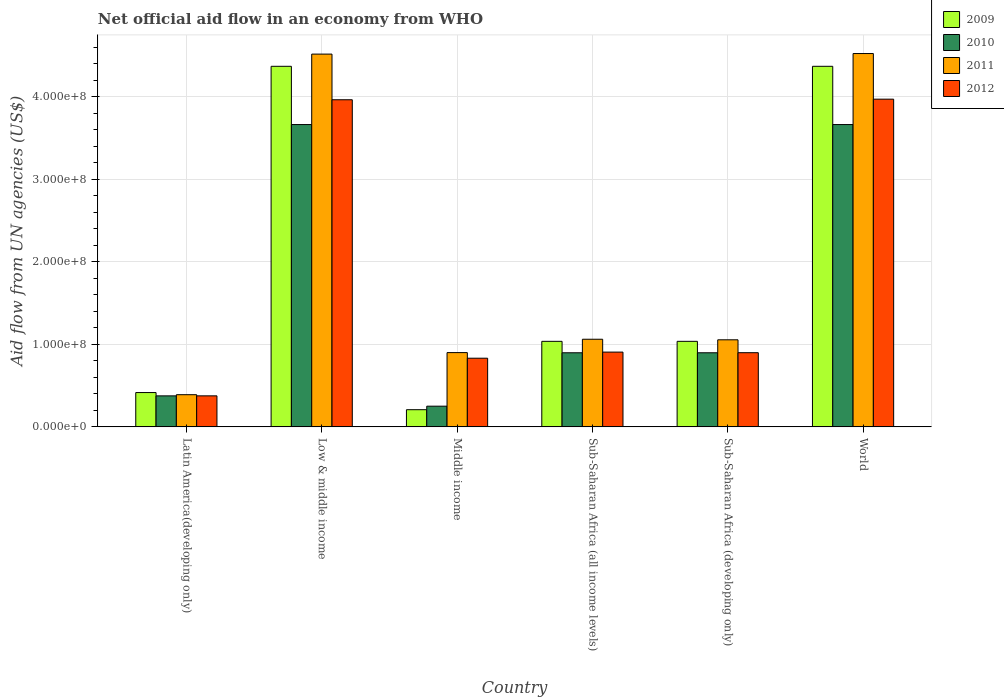How many different coloured bars are there?
Provide a short and direct response. 4. Are the number of bars per tick equal to the number of legend labels?
Provide a succinct answer. Yes. How many bars are there on the 3rd tick from the left?
Offer a terse response. 4. What is the label of the 5th group of bars from the left?
Make the answer very short. Sub-Saharan Africa (developing only). In how many cases, is the number of bars for a given country not equal to the number of legend labels?
Your answer should be compact. 0. What is the net official aid flow in 2012 in Middle income?
Ensure brevity in your answer.  8.32e+07. Across all countries, what is the maximum net official aid flow in 2011?
Ensure brevity in your answer.  4.52e+08. Across all countries, what is the minimum net official aid flow in 2012?
Give a very brief answer. 3.76e+07. In which country was the net official aid flow in 2012 minimum?
Provide a succinct answer. Latin America(developing only). What is the total net official aid flow in 2012 in the graph?
Make the answer very short. 1.09e+09. What is the difference between the net official aid flow in 2012 in Low & middle income and that in Sub-Saharan Africa (developing only)?
Keep it short and to the point. 3.06e+08. What is the difference between the net official aid flow in 2011 in World and the net official aid flow in 2009 in Middle income?
Keep it short and to the point. 4.31e+08. What is the average net official aid flow in 2009 per country?
Offer a very short reply. 1.91e+08. What is the difference between the net official aid flow of/in 2009 and net official aid flow of/in 2012 in World?
Your answer should be compact. 3.98e+07. What is the ratio of the net official aid flow in 2012 in Low & middle income to that in Sub-Saharan Africa (developing only)?
Keep it short and to the point. 4.41. Is the net official aid flow in 2010 in Low & middle income less than that in Sub-Saharan Africa (all income levels)?
Ensure brevity in your answer.  No. What is the difference between the highest and the second highest net official aid flow in 2010?
Your answer should be very brief. 2.76e+08. What is the difference between the highest and the lowest net official aid flow in 2009?
Offer a terse response. 4.16e+08. In how many countries, is the net official aid flow in 2012 greater than the average net official aid flow in 2012 taken over all countries?
Your response must be concise. 2. Is it the case that in every country, the sum of the net official aid flow in 2009 and net official aid flow in 2010 is greater than the sum of net official aid flow in 2011 and net official aid flow in 2012?
Make the answer very short. No. What does the 3rd bar from the left in World represents?
Offer a very short reply. 2011. How many countries are there in the graph?
Provide a succinct answer. 6. What is the difference between two consecutive major ticks on the Y-axis?
Offer a terse response. 1.00e+08. Does the graph contain any zero values?
Your response must be concise. No. How are the legend labels stacked?
Offer a terse response. Vertical. What is the title of the graph?
Offer a very short reply. Net official aid flow in an economy from WHO. What is the label or title of the X-axis?
Provide a succinct answer. Country. What is the label or title of the Y-axis?
Make the answer very short. Aid flow from UN agencies (US$). What is the Aid flow from UN agencies (US$) in 2009 in Latin America(developing only)?
Ensure brevity in your answer.  4.16e+07. What is the Aid flow from UN agencies (US$) of 2010 in Latin America(developing only)?
Your answer should be compact. 3.76e+07. What is the Aid flow from UN agencies (US$) in 2011 in Latin America(developing only)?
Your response must be concise. 3.90e+07. What is the Aid flow from UN agencies (US$) in 2012 in Latin America(developing only)?
Provide a succinct answer. 3.76e+07. What is the Aid flow from UN agencies (US$) of 2009 in Low & middle income?
Ensure brevity in your answer.  4.37e+08. What is the Aid flow from UN agencies (US$) of 2010 in Low & middle income?
Your response must be concise. 3.66e+08. What is the Aid flow from UN agencies (US$) in 2011 in Low & middle income?
Your answer should be compact. 4.52e+08. What is the Aid flow from UN agencies (US$) of 2012 in Low & middle income?
Your response must be concise. 3.96e+08. What is the Aid flow from UN agencies (US$) in 2009 in Middle income?
Provide a short and direct response. 2.08e+07. What is the Aid flow from UN agencies (US$) of 2010 in Middle income?
Offer a very short reply. 2.51e+07. What is the Aid flow from UN agencies (US$) in 2011 in Middle income?
Your answer should be compact. 9.00e+07. What is the Aid flow from UN agencies (US$) of 2012 in Middle income?
Provide a short and direct response. 8.32e+07. What is the Aid flow from UN agencies (US$) in 2009 in Sub-Saharan Africa (all income levels)?
Offer a very short reply. 1.04e+08. What is the Aid flow from UN agencies (US$) in 2010 in Sub-Saharan Africa (all income levels)?
Give a very brief answer. 8.98e+07. What is the Aid flow from UN agencies (US$) of 2011 in Sub-Saharan Africa (all income levels)?
Provide a succinct answer. 1.06e+08. What is the Aid flow from UN agencies (US$) of 2012 in Sub-Saharan Africa (all income levels)?
Ensure brevity in your answer.  9.06e+07. What is the Aid flow from UN agencies (US$) of 2009 in Sub-Saharan Africa (developing only)?
Give a very brief answer. 1.04e+08. What is the Aid flow from UN agencies (US$) in 2010 in Sub-Saharan Africa (developing only)?
Provide a short and direct response. 8.98e+07. What is the Aid flow from UN agencies (US$) of 2011 in Sub-Saharan Africa (developing only)?
Keep it short and to the point. 1.05e+08. What is the Aid flow from UN agencies (US$) of 2012 in Sub-Saharan Africa (developing only)?
Offer a terse response. 8.98e+07. What is the Aid flow from UN agencies (US$) in 2009 in World?
Offer a very short reply. 4.37e+08. What is the Aid flow from UN agencies (US$) in 2010 in World?
Your response must be concise. 3.66e+08. What is the Aid flow from UN agencies (US$) of 2011 in World?
Make the answer very short. 4.52e+08. What is the Aid flow from UN agencies (US$) in 2012 in World?
Make the answer very short. 3.97e+08. Across all countries, what is the maximum Aid flow from UN agencies (US$) in 2009?
Your response must be concise. 4.37e+08. Across all countries, what is the maximum Aid flow from UN agencies (US$) of 2010?
Provide a short and direct response. 3.66e+08. Across all countries, what is the maximum Aid flow from UN agencies (US$) of 2011?
Offer a terse response. 4.52e+08. Across all countries, what is the maximum Aid flow from UN agencies (US$) in 2012?
Your answer should be very brief. 3.97e+08. Across all countries, what is the minimum Aid flow from UN agencies (US$) in 2009?
Provide a short and direct response. 2.08e+07. Across all countries, what is the minimum Aid flow from UN agencies (US$) of 2010?
Your answer should be very brief. 2.51e+07. Across all countries, what is the minimum Aid flow from UN agencies (US$) in 2011?
Your answer should be compact. 3.90e+07. Across all countries, what is the minimum Aid flow from UN agencies (US$) of 2012?
Your answer should be compact. 3.76e+07. What is the total Aid flow from UN agencies (US$) in 2009 in the graph?
Offer a very short reply. 1.14e+09. What is the total Aid flow from UN agencies (US$) in 2010 in the graph?
Ensure brevity in your answer.  9.75e+08. What is the total Aid flow from UN agencies (US$) of 2011 in the graph?
Give a very brief answer. 1.24e+09. What is the total Aid flow from UN agencies (US$) of 2012 in the graph?
Your answer should be very brief. 1.09e+09. What is the difference between the Aid flow from UN agencies (US$) in 2009 in Latin America(developing only) and that in Low & middle income?
Keep it short and to the point. -3.95e+08. What is the difference between the Aid flow from UN agencies (US$) of 2010 in Latin America(developing only) and that in Low & middle income?
Provide a short and direct response. -3.29e+08. What is the difference between the Aid flow from UN agencies (US$) in 2011 in Latin America(developing only) and that in Low & middle income?
Keep it short and to the point. -4.13e+08. What is the difference between the Aid flow from UN agencies (US$) of 2012 in Latin America(developing only) and that in Low & middle income?
Your answer should be compact. -3.59e+08. What is the difference between the Aid flow from UN agencies (US$) in 2009 in Latin America(developing only) and that in Middle income?
Your response must be concise. 2.08e+07. What is the difference between the Aid flow from UN agencies (US$) of 2010 in Latin America(developing only) and that in Middle income?
Your response must be concise. 1.25e+07. What is the difference between the Aid flow from UN agencies (US$) in 2011 in Latin America(developing only) and that in Middle income?
Provide a succinct answer. -5.10e+07. What is the difference between the Aid flow from UN agencies (US$) in 2012 in Latin America(developing only) and that in Middle income?
Provide a succinct answer. -4.56e+07. What is the difference between the Aid flow from UN agencies (US$) of 2009 in Latin America(developing only) and that in Sub-Saharan Africa (all income levels)?
Your answer should be compact. -6.20e+07. What is the difference between the Aid flow from UN agencies (US$) in 2010 in Latin America(developing only) and that in Sub-Saharan Africa (all income levels)?
Provide a succinct answer. -5.22e+07. What is the difference between the Aid flow from UN agencies (US$) of 2011 in Latin America(developing only) and that in Sub-Saharan Africa (all income levels)?
Your answer should be compact. -6.72e+07. What is the difference between the Aid flow from UN agencies (US$) in 2012 in Latin America(developing only) and that in Sub-Saharan Africa (all income levels)?
Provide a succinct answer. -5.30e+07. What is the difference between the Aid flow from UN agencies (US$) of 2009 in Latin America(developing only) and that in Sub-Saharan Africa (developing only)?
Offer a terse response. -6.20e+07. What is the difference between the Aid flow from UN agencies (US$) in 2010 in Latin America(developing only) and that in Sub-Saharan Africa (developing only)?
Keep it short and to the point. -5.22e+07. What is the difference between the Aid flow from UN agencies (US$) of 2011 in Latin America(developing only) and that in Sub-Saharan Africa (developing only)?
Keep it short and to the point. -6.65e+07. What is the difference between the Aid flow from UN agencies (US$) in 2012 in Latin America(developing only) and that in Sub-Saharan Africa (developing only)?
Provide a succinct answer. -5.23e+07. What is the difference between the Aid flow from UN agencies (US$) in 2009 in Latin America(developing only) and that in World?
Offer a terse response. -3.95e+08. What is the difference between the Aid flow from UN agencies (US$) of 2010 in Latin America(developing only) and that in World?
Give a very brief answer. -3.29e+08. What is the difference between the Aid flow from UN agencies (US$) of 2011 in Latin America(developing only) and that in World?
Keep it short and to the point. -4.13e+08. What is the difference between the Aid flow from UN agencies (US$) of 2012 in Latin America(developing only) and that in World?
Give a very brief answer. -3.59e+08. What is the difference between the Aid flow from UN agencies (US$) of 2009 in Low & middle income and that in Middle income?
Ensure brevity in your answer.  4.16e+08. What is the difference between the Aid flow from UN agencies (US$) in 2010 in Low & middle income and that in Middle income?
Make the answer very short. 3.41e+08. What is the difference between the Aid flow from UN agencies (US$) of 2011 in Low & middle income and that in Middle income?
Keep it short and to the point. 3.62e+08. What is the difference between the Aid flow from UN agencies (US$) in 2012 in Low & middle income and that in Middle income?
Your answer should be compact. 3.13e+08. What is the difference between the Aid flow from UN agencies (US$) of 2009 in Low & middle income and that in Sub-Saharan Africa (all income levels)?
Make the answer very short. 3.33e+08. What is the difference between the Aid flow from UN agencies (US$) of 2010 in Low & middle income and that in Sub-Saharan Africa (all income levels)?
Provide a short and direct response. 2.76e+08. What is the difference between the Aid flow from UN agencies (US$) of 2011 in Low & middle income and that in Sub-Saharan Africa (all income levels)?
Make the answer very short. 3.45e+08. What is the difference between the Aid flow from UN agencies (US$) of 2012 in Low & middle income and that in Sub-Saharan Africa (all income levels)?
Offer a terse response. 3.06e+08. What is the difference between the Aid flow from UN agencies (US$) of 2009 in Low & middle income and that in Sub-Saharan Africa (developing only)?
Your answer should be compact. 3.33e+08. What is the difference between the Aid flow from UN agencies (US$) in 2010 in Low & middle income and that in Sub-Saharan Africa (developing only)?
Provide a short and direct response. 2.76e+08. What is the difference between the Aid flow from UN agencies (US$) in 2011 in Low & middle income and that in Sub-Saharan Africa (developing only)?
Your response must be concise. 3.46e+08. What is the difference between the Aid flow from UN agencies (US$) in 2012 in Low & middle income and that in Sub-Saharan Africa (developing only)?
Your answer should be compact. 3.06e+08. What is the difference between the Aid flow from UN agencies (US$) in 2010 in Low & middle income and that in World?
Your response must be concise. 0. What is the difference between the Aid flow from UN agencies (US$) of 2011 in Low & middle income and that in World?
Give a very brief answer. -6.70e+05. What is the difference between the Aid flow from UN agencies (US$) in 2012 in Low & middle income and that in World?
Your answer should be very brief. -7.20e+05. What is the difference between the Aid flow from UN agencies (US$) of 2009 in Middle income and that in Sub-Saharan Africa (all income levels)?
Provide a succinct answer. -8.28e+07. What is the difference between the Aid flow from UN agencies (US$) in 2010 in Middle income and that in Sub-Saharan Africa (all income levels)?
Give a very brief answer. -6.47e+07. What is the difference between the Aid flow from UN agencies (US$) in 2011 in Middle income and that in Sub-Saharan Africa (all income levels)?
Your answer should be compact. -1.62e+07. What is the difference between the Aid flow from UN agencies (US$) of 2012 in Middle income and that in Sub-Saharan Africa (all income levels)?
Provide a short and direct response. -7.39e+06. What is the difference between the Aid flow from UN agencies (US$) of 2009 in Middle income and that in Sub-Saharan Africa (developing only)?
Offer a very short reply. -8.28e+07. What is the difference between the Aid flow from UN agencies (US$) in 2010 in Middle income and that in Sub-Saharan Africa (developing only)?
Give a very brief answer. -6.47e+07. What is the difference between the Aid flow from UN agencies (US$) in 2011 in Middle income and that in Sub-Saharan Africa (developing only)?
Your answer should be very brief. -1.55e+07. What is the difference between the Aid flow from UN agencies (US$) of 2012 in Middle income and that in Sub-Saharan Africa (developing only)?
Keep it short and to the point. -6.67e+06. What is the difference between the Aid flow from UN agencies (US$) in 2009 in Middle income and that in World?
Your response must be concise. -4.16e+08. What is the difference between the Aid flow from UN agencies (US$) of 2010 in Middle income and that in World?
Offer a very short reply. -3.41e+08. What is the difference between the Aid flow from UN agencies (US$) of 2011 in Middle income and that in World?
Give a very brief answer. -3.62e+08. What is the difference between the Aid flow from UN agencies (US$) of 2012 in Middle income and that in World?
Offer a terse response. -3.14e+08. What is the difference between the Aid flow from UN agencies (US$) in 2011 in Sub-Saharan Africa (all income levels) and that in Sub-Saharan Africa (developing only)?
Ensure brevity in your answer.  6.70e+05. What is the difference between the Aid flow from UN agencies (US$) of 2012 in Sub-Saharan Africa (all income levels) and that in Sub-Saharan Africa (developing only)?
Your response must be concise. 7.20e+05. What is the difference between the Aid flow from UN agencies (US$) of 2009 in Sub-Saharan Africa (all income levels) and that in World?
Offer a terse response. -3.33e+08. What is the difference between the Aid flow from UN agencies (US$) in 2010 in Sub-Saharan Africa (all income levels) and that in World?
Ensure brevity in your answer.  -2.76e+08. What is the difference between the Aid flow from UN agencies (US$) in 2011 in Sub-Saharan Africa (all income levels) and that in World?
Offer a very short reply. -3.46e+08. What is the difference between the Aid flow from UN agencies (US$) of 2012 in Sub-Saharan Africa (all income levels) and that in World?
Your response must be concise. -3.06e+08. What is the difference between the Aid flow from UN agencies (US$) of 2009 in Sub-Saharan Africa (developing only) and that in World?
Your response must be concise. -3.33e+08. What is the difference between the Aid flow from UN agencies (US$) in 2010 in Sub-Saharan Africa (developing only) and that in World?
Ensure brevity in your answer.  -2.76e+08. What is the difference between the Aid flow from UN agencies (US$) in 2011 in Sub-Saharan Africa (developing only) and that in World?
Give a very brief answer. -3.47e+08. What is the difference between the Aid flow from UN agencies (US$) in 2012 in Sub-Saharan Africa (developing only) and that in World?
Your answer should be compact. -3.07e+08. What is the difference between the Aid flow from UN agencies (US$) of 2009 in Latin America(developing only) and the Aid flow from UN agencies (US$) of 2010 in Low & middle income?
Ensure brevity in your answer.  -3.25e+08. What is the difference between the Aid flow from UN agencies (US$) in 2009 in Latin America(developing only) and the Aid flow from UN agencies (US$) in 2011 in Low & middle income?
Make the answer very short. -4.10e+08. What is the difference between the Aid flow from UN agencies (US$) in 2009 in Latin America(developing only) and the Aid flow from UN agencies (US$) in 2012 in Low & middle income?
Your answer should be very brief. -3.55e+08. What is the difference between the Aid flow from UN agencies (US$) in 2010 in Latin America(developing only) and the Aid flow from UN agencies (US$) in 2011 in Low & middle income?
Provide a short and direct response. -4.14e+08. What is the difference between the Aid flow from UN agencies (US$) in 2010 in Latin America(developing only) and the Aid flow from UN agencies (US$) in 2012 in Low & middle income?
Keep it short and to the point. -3.59e+08. What is the difference between the Aid flow from UN agencies (US$) of 2011 in Latin America(developing only) and the Aid flow from UN agencies (US$) of 2012 in Low & middle income?
Make the answer very short. -3.57e+08. What is the difference between the Aid flow from UN agencies (US$) in 2009 in Latin America(developing only) and the Aid flow from UN agencies (US$) in 2010 in Middle income?
Provide a succinct answer. 1.65e+07. What is the difference between the Aid flow from UN agencies (US$) in 2009 in Latin America(developing only) and the Aid flow from UN agencies (US$) in 2011 in Middle income?
Provide a succinct answer. -4.84e+07. What is the difference between the Aid flow from UN agencies (US$) in 2009 in Latin America(developing only) and the Aid flow from UN agencies (US$) in 2012 in Middle income?
Ensure brevity in your answer.  -4.16e+07. What is the difference between the Aid flow from UN agencies (US$) in 2010 in Latin America(developing only) and the Aid flow from UN agencies (US$) in 2011 in Middle income?
Your answer should be very brief. -5.24e+07. What is the difference between the Aid flow from UN agencies (US$) of 2010 in Latin America(developing only) and the Aid flow from UN agencies (US$) of 2012 in Middle income?
Offer a very short reply. -4.56e+07. What is the difference between the Aid flow from UN agencies (US$) of 2011 in Latin America(developing only) and the Aid flow from UN agencies (US$) of 2012 in Middle income?
Offer a very short reply. -4.42e+07. What is the difference between the Aid flow from UN agencies (US$) of 2009 in Latin America(developing only) and the Aid flow from UN agencies (US$) of 2010 in Sub-Saharan Africa (all income levels)?
Provide a short and direct response. -4.82e+07. What is the difference between the Aid flow from UN agencies (US$) of 2009 in Latin America(developing only) and the Aid flow from UN agencies (US$) of 2011 in Sub-Saharan Africa (all income levels)?
Keep it short and to the point. -6.46e+07. What is the difference between the Aid flow from UN agencies (US$) in 2009 in Latin America(developing only) and the Aid flow from UN agencies (US$) in 2012 in Sub-Saharan Africa (all income levels)?
Offer a terse response. -4.90e+07. What is the difference between the Aid flow from UN agencies (US$) of 2010 in Latin America(developing only) and the Aid flow from UN agencies (US$) of 2011 in Sub-Saharan Africa (all income levels)?
Offer a very short reply. -6.86e+07. What is the difference between the Aid flow from UN agencies (US$) in 2010 in Latin America(developing only) and the Aid flow from UN agencies (US$) in 2012 in Sub-Saharan Africa (all income levels)?
Keep it short and to the point. -5.30e+07. What is the difference between the Aid flow from UN agencies (US$) in 2011 in Latin America(developing only) and the Aid flow from UN agencies (US$) in 2012 in Sub-Saharan Africa (all income levels)?
Offer a very short reply. -5.16e+07. What is the difference between the Aid flow from UN agencies (US$) in 2009 in Latin America(developing only) and the Aid flow from UN agencies (US$) in 2010 in Sub-Saharan Africa (developing only)?
Provide a short and direct response. -4.82e+07. What is the difference between the Aid flow from UN agencies (US$) of 2009 in Latin America(developing only) and the Aid flow from UN agencies (US$) of 2011 in Sub-Saharan Africa (developing only)?
Make the answer very short. -6.39e+07. What is the difference between the Aid flow from UN agencies (US$) in 2009 in Latin America(developing only) and the Aid flow from UN agencies (US$) in 2012 in Sub-Saharan Africa (developing only)?
Give a very brief answer. -4.83e+07. What is the difference between the Aid flow from UN agencies (US$) in 2010 in Latin America(developing only) and the Aid flow from UN agencies (US$) in 2011 in Sub-Saharan Africa (developing only)?
Your answer should be compact. -6.79e+07. What is the difference between the Aid flow from UN agencies (US$) in 2010 in Latin America(developing only) and the Aid flow from UN agencies (US$) in 2012 in Sub-Saharan Africa (developing only)?
Make the answer very short. -5.23e+07. What is the difference between the Aid flow from UN agencies (US$) of 2011 in Latin America(developing only) and the Aid flow from UN agencies (US$) of 2012 in Sub-Saharan Africa (developing only)?
Make the answer very short. -5.09e+07. What is the difference between the Aid flow from UN agencies (US$) of 2009 in Latin America(developing only) and the Aid flow from UN agencies (US$) of 2010 in World?
Your answer should be compact. -3.25e+08. What is the difference between the Aid flow from UN agencies (US$) of 2009 in Latin America(developing only) and the Aid flow from UN agencies (US$) of 2011 in World?
Provide a short and direct response. -4.11e+08. What is the difference between the Aid flow from UN agencies (US$) of 2009 in Latin America(developing only) and the Aid flow from UN agencies (US$) of 2012 in World?
Provide a succinct answer. -3.55e+08. What is the difference between the Aid flow from UN agencies (US$) of 2010 in Latin America(developing only) and the Aid flow from UN agencies (US$) of 2011 in World?
Your response must be concise. -4.15e+08. What is the difference between the Aid flow from UN agencies (US$) of 2010 in Latin America(developing only) and the Aid flow from UN agencies (US$) of 2012 in World?
Ensure brevity in your answer.  -3.59e+08. What is the difference between the Aid flow from UN agencies (US$) in 2011 in Latin America(developing only) and the Aid flow from UN agencies (US$) in 2012 in World?
Your response must be concise. -3.58e+08. What is the difference between the Aid flow from UN agencies (US$) of 2009 in Low & middle income and the Aid flow from UN agencies (US$) of 2010 in Middle income?
Your answer should be very brief. 4.12e+08. What is the difference between the Aid flow from UN agencies (US$) in 2009 in Low & middle income and the Aid flow from UN agencies (US$) in 2011 in Middle income?
Ensure brevity in your answer.  3.47e+08. What is the difference between the Aid flow from UN agencies (US$) of 2009 in Low & middle income and the Aid flow from UN agencies (US$) of 2012 in Middle income?
Ensure brevity in your answer.  3.54e+08. What is the difference between the Aid flow from UN agencies (US$) of 2010 in Low & middle income and the Aid flow from UN agencies (US$) of 2011 in Middle income?
Offer a terse response. 2.76e+08. What is the difference between the Aid flow from UN agencies (US$) in 2010 in Low & middle income and the Aid flow from UN agencies (US$) in 2012 in Middle income?
Offer a terse response. 2.83e+08. What is the difference between the Aid flow from UN agencies (US$) in 2011 in Low & middle income and the Aid flow from UN agencies (US$) in 2012 in Middle income?
Provide a short and direct response. 3.68e+08. What is the difference between the Aid flow from UN agencies (US$) of 2009 in Low & middle income and the Aid flow from UN agencies (US$) of 2010 in Sub-Saharan Africa (all income levels)?
Keep it short and to the point. 3.47e+08. What is the difference between the Aid flow from UN agencies (US$) in 2009 in Low & middle income and the Aid flow from UN agencies (US$) in 2011 in Sub-Saharan Africa (all income levels)?
Keep it short and to the point. 3.31e+08. What is the difference between the Aid flow from UN agencies (US$) in 2009 in Low & middle income and the Aid flow from UN agencies (US$) in 2012 in Sub-Saharan Africa (all income levels)?
Offer a terse response. 3.46e+08. What is the difference between the Aid flow from UN agencies (US$) in 2010 in Low & middle income and the Aid flow from UN agencies (US$) in 2011 in Sub-Saharan Africa (all income levels)?
Your answer should be very brief. 2.60e+08. What is the difference between the Aid flow from UN agencies (US$) in 2010 in Low & middle income and the Aid flow from UN agencies (US$) in 2012 in Sub-Saharan Africa (all income levels)?
Give a very brief answer. 2.76e+08. What is the difference between the Aid flow from UN agencies (US$) of 2011 in Low & middle income and the Aid flow from UN agencies (US$) of 2012 in Sub-Saharan Africa (all income levels)?
Your answer should be compact. 3.61e+08. What is the difference between the Aid flow from UN agencies (US$) of 2009 in Low & middle income and the Aid flow from UN agencies (US$) of 2010 in Sub-Saharan Africa (developing only)?
Make the answer very short. 3.47e+08. What is the difference between the Aid flow from UN agencies (US$) of 2009 in Low & middle income and the Aid flow from UN agencies (US$) of 2011 in Sub-Saharan Africa (developing only)?
Keep it short and to the point. 3.31e+08. What is the difference between the Aid flow from UN agencies (US$) in 2009 in Low & middle income and the Aid flow from UN agencies (US$) in 2012 in Sub-Saharan Africa (developing only)?
Give a very brief answer. 3.47e+08. What is the difference between the Aid flow from UN agencies (US$) in 2010 in Low & middle income and the Aid flow from UN agencies (US$) in 2011 in Sub-Saharan Africa (developing only)?
Give a very brief answer. 2.61e+08. What is the difference between the Aid flow from UN agencies (US$) of 2010 in Low & middle income and the Aid flow from UN agencies (US$) of 2012 in Sub-Saharan Africa (developing only)?
Provide a short and direct response. 2.76e+08. What is the difference between the Aid flow from UN agencies (US$) of 2011 in Low & middle income and the Aid flow from UN agencies (US$) of 2012 in Sub-Saharan Africa (developing only)?
Ensure brevity in your answer.  3.62e+08. What is the difference between the Aid flow from UN agencies (US$) of 2009 in Low & middle income and the Aid flow from UN agencies (US$) of 2010 in World?
Make the answer very short. 7.06e+07. What is the difference between the Aid flow from UN agencies (US$) of 2009 in Low & middle income and the Aid flow from UN agencies (US$) of 2011 in World?
Offer a terse response. -1.55e+07. What is the difference between the Aid flow from UN agencies (US$) in 2009 in Low & middle income and the Aid flow from UN agencies (US$) in 2012 in World?
Offer a very short reply. 3.98e+07. What is the difference between the Aid flow from UN agencies (US$) in 2010 in Low & middle income and the Aid flow from UN agencies (US$) in 2011 in World?
Give a very brief answer. -8.60e+07. What is the difference between the Aid flow from UN agencies (US$) in 2010 in Low & middle income and the Aid flow from UN agencies (US$) in 2012 in World?
Your answer should be compact. -3.08e+07. What is the difference between the Aid flow from UN agencies (US$) in 2011 in Low & middle income and the Aid flow from UN agencies (US$) in 2012 in World?
Ensure brevity in your answer.  5.46e+07. What is the difference between the Aid flow from UN agencies (US$) of 2009 in Middle income and the Aid flow from UN agencies (US$) of 2010 in Sub-Saharan Africa (all income levels)?
Make the answer very short. -6.90e+07. What is the difference between the Aid flow from UN agencies (US$) in 2009 in Middle income and the Aid flow from UN agencies (US$) in 2011 in Sub-Saharan Africa (all income levels)?
Make the answer very short. -8.54e+07. What is the difference between the Aid flow from UN agencies (US$) of 2009 in Middle income and the Aid flow from UN agencies (US$) of 2012 in Sub-Saharan Africa (all income levels)?
Your answer should be compact. -6.98e+07. What is the difference between the Aid flow from UN agencies (US$) in 2010 in Middle income and the Aid flow from UN agencies (US$) in 2011 in Sub-Saharan Africa (all income levels)?
Keep it short and to the point. -8.11e+07. What is the difference between the Aid flow from UN agencies (US$) of 2010 in Middle income and the Aid flow from UN agencies (US$) of 2012 in Sub-Saharan Africa (all income levels)?
Offer a very short reply. -6.55e+07. What is the difference between the Aid flow from UN agencies (US$) in 2011 in Middle income and the Aid flow from UN agencies (US$) in 2012 in Sub-Saharan Africa (all income levels)?
Your response must be concise. -5.90e+05. What is the difference between the Aid flow from UN agencies (US$) of 2009 in Middle income and the Aid flow from UN agencies (US$) of 2010 in Sub-Saharan Africa (developing only)?
Your answer should be compact. -6.90e+07. What is the difference between the Aid flow from UN agencies (US$) in 2009 in Middle income and the Aid flow from UN agencies (US$) in 2011 in Sub-Saharan Africa (developing only)?
Your answer should be compact. -8.47e+07. What is the difference between the Aid flow from UN agencies (US$) of 2009 in Middle income and the Aid flow from UN agencies (US$) of 2012 in Sub-Saharan Africa (developing only)?
Offer a terse response. -6.90e+07. What is the difference between the Aid flow from UN agencies (US$) of 2010 in Middle income and the Aid flow from UN agencies (US$) of 2011 in Sub-Saharan Africa (developing only)?
Your response must be concise. -8.04e+07. What is the difference between the Aid flow from UN agencies (US$) in 2010 in Middle income and the Aid flow from UN agencies (US$) in 2012 in Sub-Saharan Africa (developing only)?
Provide a short and direct response. -6.48e+07. What is the difference between the Aid flow from UN agencies (US$) of 2009 in Middle income and the Aid flow from UN agencies (US$) of 2010 in World?
Ensure brevity in your answer.  -3.45e+08. What is the difference between the Aid flow from UN agencies (US$) of 2009 in Middle income and the Aid flow from UN agencies (US$) of 2011 in World?
Your answer should be very brief. -4.31e+08. What is the difference between the Aid flow from UN agencies (US$) of 2009 in Middle income and the Aid flow from UN agencies (US$) of 2012 in World?
Offer a very short reply. -3.76e+08. What is the difference between the Aid flow from UN agencies (US$) of 2010 in Middle income and the Aid flow from UN agencies (US$) of 2011 in World?
Your answer should be very brief. -4.27e+08. What is the difference between the Aid flow from UN agencies (US$) in 2010 in Middle income and the Aid flow from UN agencies (US$) in 2012 in World?
Ensure brevity in your answer.  -3.72e+08. What is the difference between the Aid flow from UN agencies (US$) in 2011 in Middle income and the Aid flow from UN agencies (US$) in 2012 in World?
Your answer should be very brief. -3.07e+08. What is the difference between the Aid flow from UN agencies (US$) of 2009 in Sub-Saharan Africa (all income levels) and the Aid flow from UN agencies (US$) of 2010 in Sub-Saharan Africa (developing only)?
Provide a short and direct response. 1.39e+07. What is the difference between the Aid flow from UN agencies (US$) of 2009 in Sub-Saharan Africa (all income levels) and the Aid flow from UN agencies (US$) of 2011 in Sub-Saharan Africa (developing only)?
Keep it short and to the point. -1.86e+06. What is the difference between the Aid flow from UN agencies (US$) in 2009 in Sub-Saharan Africa (all income levels) and the Aid flow from UN agencies (US$) in 2012 in Sub-Saharan Africa (developing only)?
Make the answer very short. 1.38e+07. What is the difference between the Aid flow from UN agencies (US$) in 2010 in Sub-Saharan Africa (all income levels) and the Aid flow from UN agencies (US$) in 2011 in Sub-Saharan Africa (developing only)?
Make the answer very short. -1.57e+07. What is the difference between the Aid flow from UN agencies (US$) in 2011 in Sub-Saharan Africa (all income levels) and the Aid flow from UN agencies (US$) in 2012 in Sub-Saharan Africa (developing only)?
Make the answer very short. 1.63e+07. What is the difference between the Aid flow from UN agencies (US$) in 2009 in Sub-Saharan Africa (all income levels) and the Aid flow from UN agencies (US$) in 2010 in World?
Make the answer very short. -2.63e+08. What is the difference between the Aid flow from UN agencies (US$) of 2009 in Sub-Saharan Africa (all income levels) and the Aid flow from UN agencies (US$) of 2011 in World?
Keep it short and to the point. -3.49e+08. What is the difference between the Aid flow from UN agencies (US$) in 2009 in Sub-Saharan Africa (all income levels) and the Aid flow from UN agencies (US$) in 2012 in World?
Offer a terse response. -2.93e+08. What is the difference between the Aid flow from UN agencies (US$) of 2010 in Sub-Saharan Africa (all income levels) and the Aid flow from UN agencies (US$) of 2011 in World?
Ensure brevity in your answer.  -3.62e+08. What is the difference between the Aid flow from UN agencies (US$) of 2010 in Sub-Saharan Africa (all income levels) and the Aid flow from UN agencies (US$) of 2012 in World?
Make the answer very short. -3.07e+08. What is the difference between the Aid flow from UN agencies (US$) in 2011 in Sub-Saharan Africa (all income levels) and the Aid flow from UN agencies (US$) in 2012 in World?
Make the answer very short. -2.91e+08. What is the difference between the Aid flow from UN agencies (US$) of 2009 in Sub-Saharan Africa (developing only) and the Aid flow from UN agencies (US$) of 2010 in World?
Give a very brief answer. -2.63e+08. What is the difference between the Aid flow from UN agencies (US$) of 2009 in Sub-Saharan Africa (developing only) and the Aid flow from UN agencies (US$) of 2011 in World?
Give a very brief answer. -3.49e+08. What is the difference between the Aid flow from UN agencies (US$) in 2009 in Sub-Saharan Africa (developing only) and the Aid flow from UN agencies (US$) in 2012 in World?
Provide a succinct answer. -2.93e+08. What is the difference between the Aid flow from UN agencies (US$) of 2010 in Sub-Saharan Africa (developing only) and the Aid flow from UN agencies (US$) of 2011 in World?
Your response must be concise. -3.62e+08. What is the difference between the Aid flow from UN agencies (US$) in 2010 in Sub-Saharan Africa (developing only) and the Aid flow from UN agencies (US$) in 2012 in World?
Give a very brief answer. -3.07e+08. What is the difference between the Aid flow from UN agencies (US$) in 2011 in Sub-Saharan Africa (developing only) and the Aid flow from UN agencies (US$) in 2012 in World?
Offer a very short reply. -2.92e+08. What is the average Aid flow from UN agencies (US$) of 2009 per country?
Your answer should be very brief. 1.91e+08. What is the average Aid flow from UN agencies (US$) of 2010 per country?
Provide a succinct answer. 1.62e+08. What is the average Aid flow from UN agencies (US$) of 2011 per country?
Provide a succinct answer. 2.07e+08. What is the average Aid flow from UN agencies (US$) in 2012 per country?
Your response must be concise. 1.82e+08. What is the difference between the Aid flow from UN agencies (US$) of 2009 and Aid flow from UN agencies (US$) of 2010 in Latin America(developing only)?
Provide a succinct answer. 4.01e+06. What is the difference between the Aid flow from UN agencies (US$) of 2009 and Aid flow from UN agencies (US$) of 2011 in Latin America(developing only)?
Provide a short and direct response. 2.59e+06. What is the difference between the Aid flow from UN agencies (US$) of 2009 and Aid flow from UN agencies (US$) of 2012 in Latin America(developing only)?
Give a very brief answer. 3.99e+06. What is the difference between the Aid flow from UN agencies (US$) in 2010 and Aid flow from UN agencies (US$) in 2011 in Latin America(developing only)?
Ensure brevity in your answer.  -1.42e+06. What is the difference between the Aid flow from UN agencies (US$) of 2010 and Aid flow from UN agencies (US$) of 2012 in Latin America(developing only)?
Keep it short and to the point. -2.00e+04. What is the difference between the Aid flow from UN agencies (US$) of 2011 and Aid flow from UN agencies (US$) of 2012 in Latin America(developing only)?
Your answer should be compact. 1.40e+06. What is the difference between the Aid flow from UN agencies (US$) in 2009 and Aid flow from UN agencies (US$) in 2010 in Low & middle income?
Offer a terse response. 7.06e+07. What is the difference between the Aid flow from UN agencies (US$) in 2009 and Aid flow from UN agencies (US$) in 2011 in Low & middle income?
Provide a succinct answer. -1.48e+07. What is the difference between the Aid flow from UN agencies (US$) in 2009 and Aid flow from UN agencies (US$) in 2012 in Low & middle income?
Make the answer very short. 4.05e+07. What is the difference between the Aid flow from UN agencies (US$) of 2010 and Aid flow from UN agencies (US$) of 2011 in Low & middle income?
Offer a very short reply. -8.54e+07. What is the difference between the Aid flow from UN agencies (US$) in 2010 and Aid flow from UN agencies (US$) in 2012 in Low & middle income?
Make the answer very short. -3.00e+07. What is the difference between the Aid flow from UN agencies (US$) of 2011 and Aid flow from UN agencies (US$) of 2012 in Low & middle income?
Provide a short and direct response. 5.53e+07. What is the difference between the Aid flow from UN agencies (US$) in 2009 and Aid flow from UN agencies (US$) in 2010 in Middle income?
Your answer should be very brief. -4.27e+06. What is the difference between the Aid flow from UN agencies (US$) of 2009 and Aid flow from UN agencies (US$) of 2011 in Middle income?
Make the answer very short. -6.92e+07. What is the difference between the Aid flow from UN agencies (US$) of 2009 and Aid flow from UN agencies (US$) of 2012 in Middle income?
Provide a short and direct response. -6.24e+07. What is the difference between the Aid flow from UN agencies (US$) in 2010 and Aid flow from UN agencies (US$) in 2011 in Middle income?
Keep it short and to the point. -6.49e+07. What is the difference between the Aid flow from UN agencies (US$) in 2010 and Aid flow from UN agencies (US$) in 2012 in Middle income?
Your answer should be compact. -5.81e+07. What is the difference between the Aid flow from UN agencies (US$) in 2011 and Aid flow from UN agencies (US$) in 2012 in Middle income?
Ensure brevity in your answer.  6.80e+06. What is the difference between the Aid flow from UN agencies (US$) of 2009 and Aid flow from UN agencies (US$) of 2010 in Sub-Saharan Africa (all income levels)?
Make the answer very short. 1.39e+07. What is the difference between the Aid flow from UN agencies (US$) in 2009 and Aid flow from UN agencies (US$) in 2011 in Sub-Saharan Africa (all income levels)?
Provide a succinct answer. -2.53e+06. What is the difference between the Aid flow from UN agencies (US$) in 2009 and Aid flow from UN agencies (US$) in 2012 in Sub-Saharan Africa (all income levels)?
Ensure brevity in your answer.  1.30e+07. What is the difference between the Aid flow from UN agencies (US$) of 2010 and Aid flow from UN agencies (US$) of 2011 in Sub-Saharan Africa (all income levels)?
Offer a terse response. -1.64e+07. What is the difference between the Aid flow from UN agencies (US$) of 2010 and Aid flow from UN agencies (US$) of 2012 in Sub-Saharan Africa (all income levels)?
Ensure brevity in your answer.  -8.10e+05. What is the difference between the Aid flow from UN agencies (US$) of 2011 and Aid flow from UN agencies (US$) of 2012 in Sub-Saharan Africa (all income levels)?
Make the answer very short. 1.56e+07. What is the difference between the Aid flow from UN agencies (US$) of 2009 and Aid flow from UN agencies (US$) of 2010 in Sub-Saharan Africa (developing only)?
Provide a short and direct response. 1.39e+07. What is the difference between the Aid flow from UN agencies (US$) in 2009 and Aid flow from UN agencies (US$) in 2011 in Sub-Saharan Africa (developing only)?
Provide a succinct answer. -1.86e+06. What is the difference between the Aid flow from UN agencies (US$) of 2009 and Aid flow from UN agencies (US$) of 2012 in Sub-Saharan Africa (developing only)?
Keep it short and to the point. 1.38e+07. What is the difference between the Aid flow from UN agencies (US$) in 2010 and Aid flow from UN agencies (US$) in 2011 in Sub-Saharan Africa (developing only)?
Make the answer very short. -1.57e+07. What is the difference between the Aid flow from UN agencies (US$) in 2011 and Aid flow from UN agencies (US$) in 2012 in Sub-Saharan Africa (developing only)?
Your answer should be compact. 1.56e+07. What is the difference between the Aid flow from UN agencies (US$) of 2009 and Aid flow from UN agencies (US$) of 2010 in World?
Make the answer very short. 7.06e+07. What is the difference between the Aid flow from UN agencies (US$) of 2009 and Aid flow from UN agencies (US$) of 2011 in World?
Offer a terse response. -1.55e+07. What is the difference between the Aid flow from UN agencies (US$) in 2009 and Aid flow from UN agencies (US$) in 2012 in World?
Keep it short and to the point. 3.98e+07. What is the difference between the Aid flow from UN agencies (US$) of 2010 and Aid flow from UN agencies (US$) of 2011 in World?
Your response must be concise. -8.60e+07. What is the difference between the Aid flow from UN agencies (US$) in 2010 and Aid flow from UN agencies (US$) in 2012 in World?
Ensure brevity in your answer.  -3.08e+07. What is the difference between the Aid flow from UN agencies (US$) of 2011 and Aid flow from UN agencies (US$) of 2012 in World?
Provide a succinct answer. 5.53e+07. What is the ratio of the Aid flow from UN agencies (US$) of 2009 in Latin America(developing only) to that in Low & middle income?
Offer a very short reply. 0.1. What is the ratio of the Aid flow from UN agencies (US$) of 2010 in Latin America(developing only) to that in Low & middle income?
Keep it short and to the point. 0.1. What is the ratio of the Aid flow from UN agencies (US$) of 2011 in Latin America(developing only) to that in Low & middle income?
Your response must be concise. 0.09. What is the ratio of the Aid flow from UN agencies (US$) of 2012 in Latin America(developing only) to that in Low & middle income?
Give a very brief answer. 0.09. What is the ratio of the Aid flow from UN agencies (US$) of 2009 in Latin America(developing only) to that in Middle income?
Your answer should be very brief. 2. What is the ratio of the Aid flow from UN agencies (US$) of 2010 in Latin America(developing only) to that in Middle income?
Ensure brevity in your answer.  1.5. What is the ratio of the Aid flow from UN agencies (US$) in 2011 in Latin America(developing only) to that in Middle income?
Give a very brief answer. 0.43. What is the ratio of the Aid flow from UN agencies (US$) of 2012 in Latin America(developing only) to that in Middle income?
Keep it short and to the point. 0.45. What is the ratio of the Aid flow from UN agencies (US$) in 2009 in Latin America(developing only) to that in Sub-Saharan Africa (all income levels)?
Your response must be concise. 0.4. What is the ratio of the Aid flow from UN agencies (US$) in 2010 in Latin America(developing only) to that in Sub-Saharan Africa (all income levels)?
Your response must be concise. 0.42. What is the ratio of the Aid flow from UN agencies (US$) of 2011 in Latin America(developing only) to that in Sub-Saharan Africa (all income levels)?
Provide a short and direct response. 0.37. What is the ratio of the Aid flow from UN agencies (US$) of 2012 in Latin America(developing only) to that in Sub-Saharan Africa (all income levels)?
Provide a short and direct response. 0.41. What is the ratio of the Aid flow from UN agencies (US$) in 2009 in Latin America(developing only) to that in Sub-Saharan Africa (developing only)?
Your response must be concise. 0.4. What is the ratio of the Aid flow from UN agencies (US$) in 2010 in Latin America(developing only) to that in Sub-Saharan Africa (developing only)?
Ensure brevity in your answer.  0.42. What is the ratio of the Aid flow from UN agencies (US$) in 2011 in Latin America(developing only) to that in Sub-Saharan Africa (developing only)?
Give a very brief answer. 0.37. What is the ratio of the Aid flow from UN agencies (US$) in 2012 in Latin America(developing only) to that in Sub-Saharan Africa (developing only)?
Provide a succinct answer. 0.42. What is the ratio of the Aid flow from UN agencies (US$) in 2009 in Latin America(developing only) to that in World?
Make the answer very short. 0.1. What is the ratio of the Aid flow from UN agencies (US$) in 2010 in Latin America(developing only) to that in World?
Your response must be concise. 0.1. What is the ratio of the Aid flow from UN agencies (US$) in 2011 in Latin America(developing only) to that in World?
Provide a short and direct response. 0.09. What is the ratio of the Aid flow from UN agencies (US$) of 2012 in Latin America(developing only) to that in World?
Your response must be concise. 0.09. What is the ratio of the Aid flow from UN agencies (US$) of 2009 in Low & middle income to that in Middle income?
Your answer should be compact. 21. What is the ratio of the Aid flow from UN agencies (US$) in 2010 in Low & middle income to that in Middle income?
Keep it short and to the point. 14.61. What is the ratio of the Aid flow from UN agencies (US$) of 2011 in Low & middle income to that in Middle income?
Ensure brevity in your answer.  5.02. What is the ratio of the Aid flow from UN agencies (US$) in 2012 in Low & middle income to that in Middle income?
Provide a succinct answer. 4.76. What is the ratio of the Aid flow from UN agencies (US$) in 2009 in Low & middle income to that in Sub-Saharan Africa (all income levels)?
Ensure brevity in your answer.  4.22. What is the ratio of the Aid flow from UN agencies (US$) of 2010 in Low & middle income to that in Sub-Saharan Africa (all income levels)?
Offer a terse response. 4.08. What is the ratio of the Aid flow from UN agencies (US$) in 2011 in Low & middle income to that in Sub-Saharan Africa (all income levels)?
Your answer should be very brief. 4.25. What is the ratio of the Aid flow from UN agencies (US$) of 2012 in Low & middle income to that in Sub-Saharan Africa (all income levels)?
Provide a succinct answer. 4.38. What is the ratio of the Aid flow from UN agencies (US$) in 2009 in Low & middle income to that in Sub-Saharan Africa (developing only)?
Provide a short and direct response. 4.22. What is the ratio of the Aid flow from UN agencies (US$) in 2010 in Low & middle income to that in Sub-Saharan Africa (developing only)?
Offer a very short reply. 4.08. What is the ratio of the Aid flow from UN agencies (US$) in 2011 in Low & middle income to that in Sub-Saharan Africa (developing only)?
Offer a very short reply. 4.28. What is the ratio of the Aid flow from UN agencies (US$) in 2012 in Low & middle income to that in Sub-Saharan Africa (developing only)?
Keep it short and to the point. 4.41. What is the ratio of the Aid flow from UN agencies (US$) in 2009 in Low & middle income to that in World?
Ensure brevity in your answer.  1. What is the ratio of the Aid flow from UN agencies (US$) in 2010 in Low & middle income to that in World?
Your answer should be compact. 1. What is the ratio of the Aid flow from UN agencies (US$) of 2011 in Low & middle income to that in World?
Offer a very short reply. 1. What is the ratio of the Aid flow from UN agencies (US$) of 2012 in Low & middle income to that in World?
Your answer should be very brief. 1. What is the ratio of the Aid flow from UN agencies (US$) of 2009 in Middle income to that in Sub-Saharan Africa (all income levels)?
Offer a very short reply. 0.2. What is the ratio of the Aid flow from UN agencies (US$) in 2010 in Middle income to that in Sub-Saharan Africa (all income levels)?
Keep it short and to the point. 0.28. What is the ratio of the Aid flow from UN agencies (US$) in 2011 in Middle income to that in Sub-Saharan Africa (all income levels)?
Your answer should be very brief. 0.85. What is the ratio of the Aid flow from UN agencies (US$) in 2012 in Middle income to that in Sub-Saharan Africa (all income levels)?
Make the answer very short. 0.92. What is the ratio of the Aid flow from UN agencies (US$) of 2009 in Middle income to that in Sub-Saharan Africa (developing only)?
Offer a terse response. 0.2. What is the ratio of the Aid flow from UN agencies (US$) of 2010 in Middle income to that in Sub-Saharan Africa (developing only)?
Your answer should be very brief. 0.28. What is the ratio of the Aid flow from UN agencies (US$) of 2011 in Middle income to that in Sub-Saharan Africa (developing only)?
Provide a succinct answer. 0.85. What is the ratio of the Aid flow from UN agencies (US$) in 2012 in Middle income to that in Sub-Saharan Africa (developing only)?
Offer a terse response. 0.93. What is the ratio of the Aid flow from UN agencies (US$) of 2009 in Middle income to that in World?
Your answer should be compact. 0.05. What is the ratio of the Aid flow from UN agencies (US$) of 2010 in Middle income to that in World?
Provide a succinct answer. 0.07. What is the ratio of the Aid flow from UN agencies (US$) in 2011 in Middle income to that in World?
Provide a short and direct response. 0.2. What is the ratio of the Aid flow from UN agencies (US$) of 2012 in Middle income to that in World?
Keep it short and to the point. 0.21. What is the ratio of the Aid flow from UN agencies (US$) of 2011 in Sub-Saharan Africa (all income levels) to that in Sub-Saharan Africa (developing only)?
Make the answer very short. 1.01. What is the ratio of the Aid flow from UN agencies (US$) of 2009 in Sub-Saharan Africa (all income levels) to that in World?
Your response must be concise. 0.24. What is the ratio of the Aid flow from UN agencies (US$) of 2010 in Sub-Saharan Africa (all income levels) to that in World?
Offer a very short reply. 0.25. What is the ratio of the Aid flow from UN agencies (US$) in 2011 in Sub-Saharan Africa (all income levels) to that in World?
Provide a succinct answer. 0.23. What is the ratio of the Aid flow from UN agencies (US$) in 2012 in Sub-Saharan Africa (all income levels) to that in World?
Provide a short and direct response. 0.23. What is the ratio of the Aid flow from UN agencies (US$) of 2009 in Sub-Saharan Africa (developing only) to that in World?
Your response must be concise. 0.24. What is the ratio of the Aid flow from UN agencies (US$) of 2010 in Sub-Saharan Africa (developing only) to that in World?
Ensure brevity in your answer.  0.25. What is the ratio of the Aid flow from UN agencies (US$) in 2011 in Sub-Saharan Africa (developing only) to that in World?
Provide a short and direct response. 0.23. What is the ratio of the Aid flow from UN agencies (US$) in 2012 in Sub-Saharan Africa (developing only) to that in World?
Your answer should be compact. 0.23. What is the difference between the highest and the second highest Aid flow from UN agencies (US$) of 2011?
Offer a very short reply. 6.70e+05. What is the difference between the highest and the second highest Aid flow from UN agencies (US$) of 2012?
Ensure brevity in your answer.  7.20e+05. What is the difference between the highest and the lowest Aid flow from UN agencies (US$) in 2009?
Your answer should be very brief. 4.16e+08. What is the difference between the highest and the lowest Aid flow from UN agencies (US$) in 2010?
Make the answer very short. 3.41e+08. What is the difference between the highest and the lowest Aid flow from UN agencies (US$) of 2011?
Offer a terse response. 4.13e+08. What is the difference between the highest and the lowest Aid flow from UN agencies (US$) of 2012?
Give a very brief answer. 3.59e+08. 